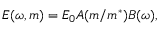Convert formula to latex. <formula><loc_0><loc_0><loc_500><loc_500>E ( \omega , m ) = E _ { 0 } A ( m / m ^ { * } ) B ( \omega ) ,</formula> 